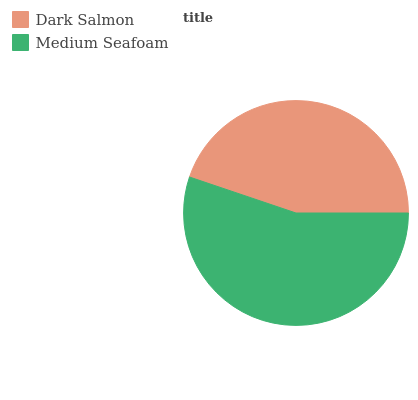Is Dark Salmon the minimum?
Answer yes or no. Yes. Is Medium Seafoam the maximum?
Answer yes or no. Yes. Is Medium Seafoam the minimum?
Answer yes or no. No. Is Medium Seafoam greater than Dark Salmon?
Answer yes or no. Yes. Is Dark Salmon less than Medium Seafoam?
Answer yes or no. Yes. Is Dark Salmon greater than Medium Seafoam?
Answer yes or no. No. Is Medium Seafoam less than Dark Salmon?
Answer yes or no. No. Is Medium Seafoam the high median?
Answer yes or no. Yes. Is Dark Salmon the low median?
Answer yes or no. Yes. Is Dark Salmon the high median?
Answer yes or no. No. Is Medium Seafoam the low median?
Answer yes or no. No. 